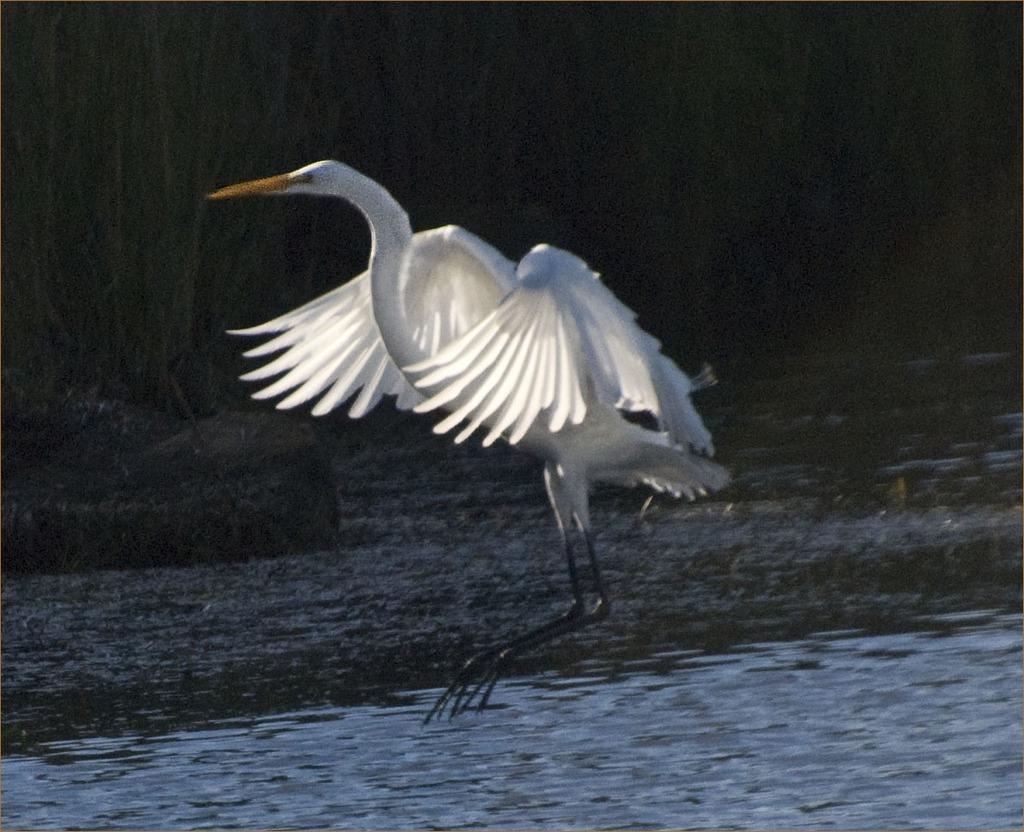What is the main subject of the image? The main subject of the image is a crane. What is present at the bottom of the image? There is water at the bottom of the image. How would you describe the overall lighting in the image? The background of the image is dark. How many frogs are contributing to the storyline in the image? There are no frogs present in the image, so they cannot contribute to any storyline. 